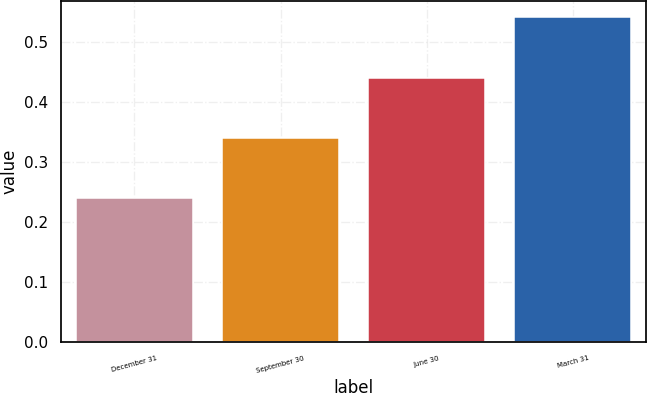Convert chart. <chart><loc_0><loc_0><loc_500><loc_500><bar_chart><fcel>December 31<fcel>September 30<fcel>June 30<fcel>March 31<nl><fcel>0.24<fcel>0.34<fcel>0.44<fcel>0.54<nl></chart> 